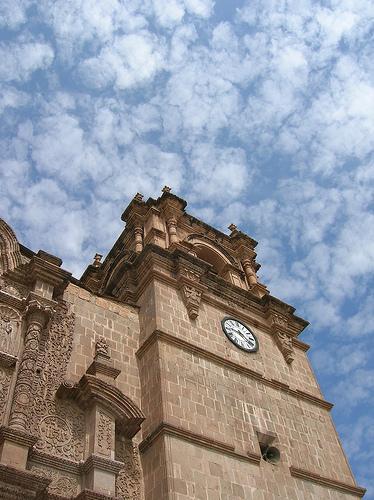How many columns?
Give a very brief answer. 6. How many clocks are pictured?
Give a very brief answer. 1. How many people are pictured?
Give a very brief answer. 0. How many elephants are pictured?
Give a very brief answer. 0. How many dinosaurs are in the picture?
Give a very brief answer. 0. 